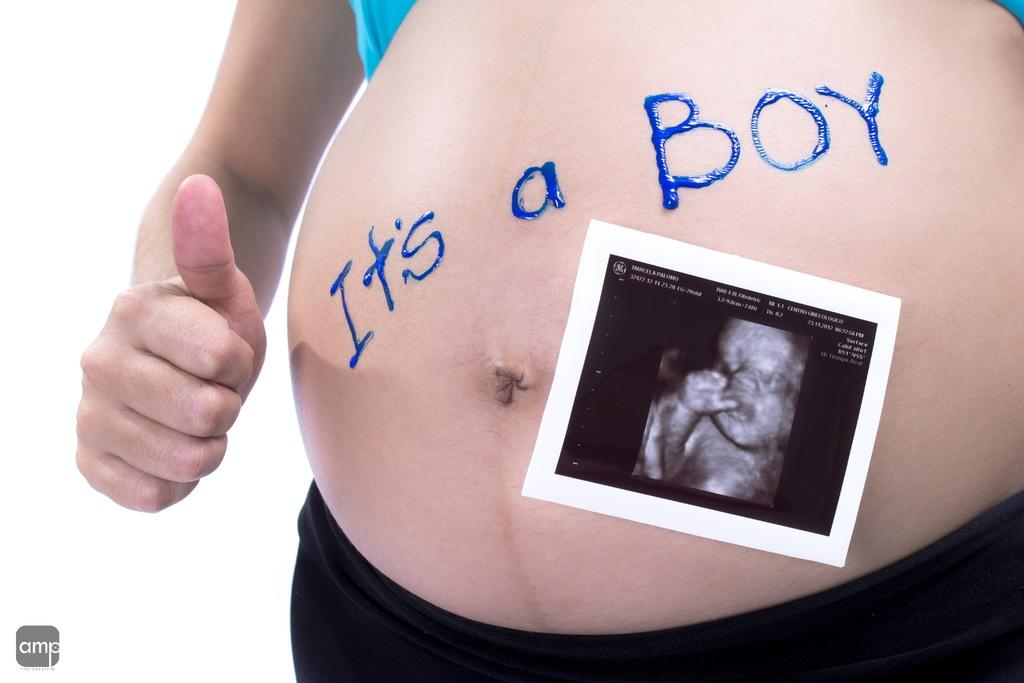What is attached to the woman's belly in the image? There is a photograph attached to the woman's belly in the image. What else can be seen on the woman's belly? There is text on the woman's belly in the image. Can you describe the logo at the bottom of the image? Yes, there is a logo at the bottom of the image. Can you see a giraffe hiding in the cave in the image? There is no giraffe or cave present in the image. What process is being depicted in the image? The image does not depict a process; it shows a photograph attached to a woman's belly with text and a logo at the bottom. 